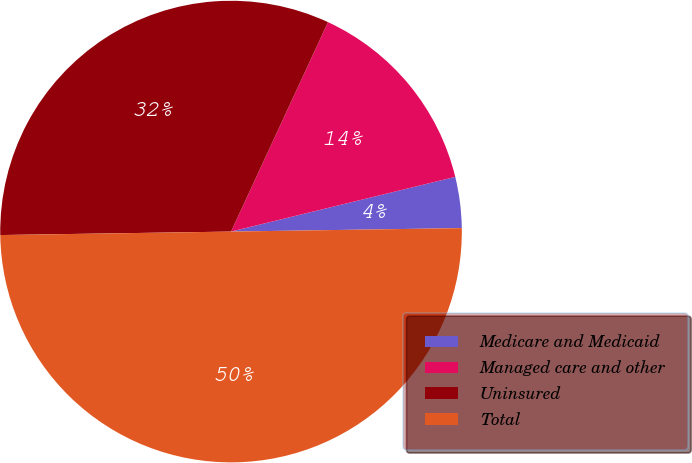<chart> <loc_0><loc_0><loc_500><loc_500><pie_chart><fcel>Medicare and Medicaid<fcel>Managed care and other<fcel>Uninsured<fcel>Total<nl><fcel>3.57%<fcel>14.29%<fcel>32.14%<fcel>50.0%<nl></chart> 